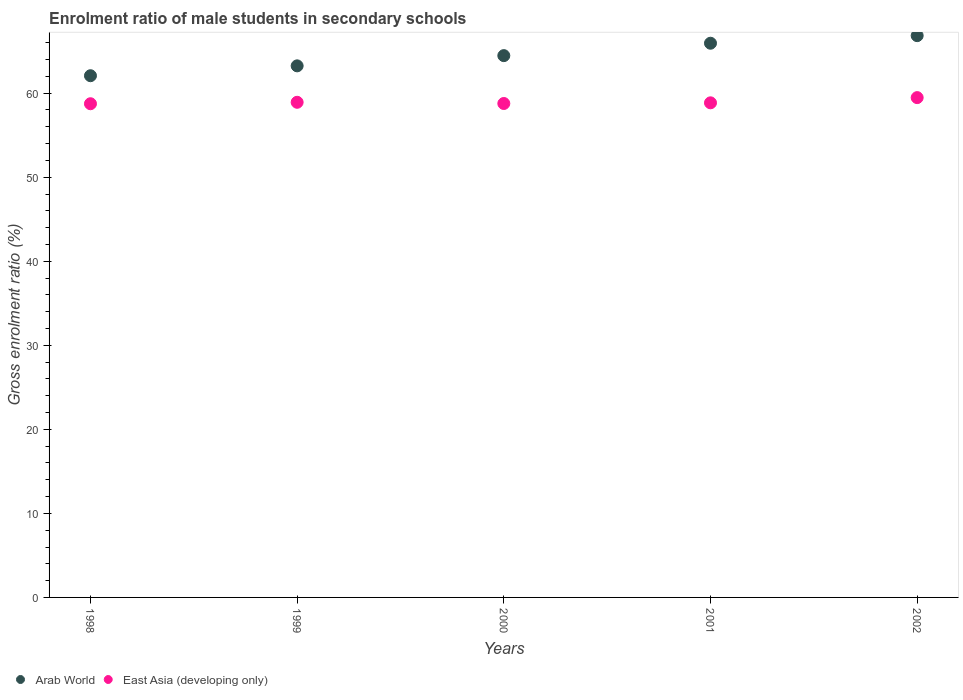Is the number of dotlines equal to the number of legend labels?
Your answer should be very brief. Yes. What is the enrolment ratio of male students in secondary schools in Arab World in 2000?
Your response must be concise. 64.47. Across all years, what is the maximum enrolment ratio of male students in secondary schools in East Asia (developing only)?
Your response must be concise. 59.47. Across all years, what is the minimum enrolment ratio of male students in secondary schools in Arab World?
Provide a succinct answer. 62.08. In which year was the enrolment ratio of male students in secondary schools in Arab World minimum?
Offer a terse response. 1998. What is the total enrolment ratio of male students in secondary schools in Arab World in the graph?
Ensure brevity in your answer.  322.58. What is the difference between the enrolment ratio of male students in secondary schools in East Asia (developing only) in 2000 and that in 2001?
Provide a succinct answer. -0.08. What is the difference between the enrolment ratio of male students in secondary schools in Arab World in 2001 and the enrolment ratio of male students in secondary schools in East Asia (developing only) in 2000?
Your answer should be compact. 7.17. What is the average enrolment ratio of male students in secondary schools in East Asia (developing only) per year?
Keep it short and to the point. 58.95. In the year 1999, what is the difference between the enrolment ratio of male students in secondary schools in Arab World and enrolment ratio of male students in secondary schools in East Asia (developing only)?
Provide a succinct answer. 4.33. What is the ratio of the enrolment ratio of male students in secondary schools in Arab World in 1998 to that in 2000?
Keep it short and to the point. 0.96. Is the enrolment ratio of male students in secondary schools in East Asia (developing only) in 1998 less than that in 2002?
Make the answer very short. Yes. What is the difference between the highest and the second highest enrolment ratio of male students in secondary schools in Arab World?
Offer a very short reply. 0.9. What is the difference between the highest and the lowest enrolment ratio of male students in secondary schools in East Asia (developing only)?
Offer a terse response. 0.73. Does the enrolment ratio of male students in secondary schools in Arab World monotonically increase over the years?
Offer a terse response. Yes. Is the enrolment ratio of male students in secondary schools in East Asia (developing only) strictly less than the enrolment ratio of male students in secondary schools in Arab World over the years?
Make the answer very short. Yes. How many dotlines are there?
Your response must be concise. 2. How many years are there in the graph?
Provide a succinct answer. 5. Are the values on the major ticks of Y-axis written in scientific E-notation?
Ensure brevity in your answer.  No. Does the graph contain grids?
Provide a succinct answer. No. Where does the legend appear in the graph?
Give a very brief answer. Bottom left. How many legend labels are there?
Your response must be concise. 2. How are the legend labels stacked?
Ensure brevity in your answer.  Horizontal. What is the title of the graph?
Give a very brief answer. Enrolment ratio of male students in secondary schools. Does "Nepal" appear as one of the legend labels in the graph?
Keep it short and to the point. No. What is the label or title of the X-axis?
Keep it short and to the point. Years. What is the Gross enrolment ratio (%) of Arab World in 1998?
Offer a very short reply. 62.08. What is the Gross enrolment ratio (%) in East Asia (developing only) in 1998?
Your response must be concise. 58.74. What is the Gross enrolment ratio (%) of Arab World in 1999?
Your answer should be very brief. 63.25. What is the Gross enrolment ratio (%) of East Asia (developing only) in 1999?
Offer a terse response. 58.92. What is the Gross enrolment ratio (%) of Arab World in 2000?
Offer a very short reply. 64.47. What is the Gross enrolment ratio (%) of East Asia (developing only) in 2000?
Give a very brief answer. 58.77. What is the Gross enrolment ratio (%) of Arab World in 2001?
Provide a succinct answer. 65.94. What is the Gross enrolment ratio (%) in East Asia (developing only) in 2001?
Your response must be concise. 58.85. What is the Gross enrolment ratio (%) in Arab World in 2002?
Make the answer very short. 66.84. What is the Gross enrolment ratio (%) of East Asia (developing only) in 2002?
Your answer should be very brief. 59.47. Across all years, what is the maximum Gross enrolment ratio (%) in Arab World?
Keep it short and to the point. 66.84. Across all years, what is the maximum Gross enrolment ratio (%) in East Asia (developing only)?
Offer a terse response. 59.47. Across all years, what is the minimum Gross enrolment ratio (%) of Arab World?
Make the answer very short. 62.08. Across all years, what is the minimum Gross enrolment ratio (%) in East Asia (developing only)?
Your response must be concise. 58.74. What is the total Gross enrolment ratio (%) in Arab World in the graph?
Your answer should be very brief. 322.58. What is the total Gross enrolment ratio (%) of East Asia (developing only) in the graph?
Offer a terse response. 294.75. What is the difference between the Gross enrolment ratio (%) of Arab World in 1998 and that in 1999?
Provide a short and direct response. -1.17. What is the difference between the Gross enrolment ratio (%) in East Asia (developing only) in 1998 and that in 1999?
Give a very brief answer. -0.17. What is the difference between the Gross enrolment ratio (%) of Arab World in 1998 and that in 2000?
Your answer should be very brief. -2.39. What is the difference between the Gross enrolment ratio (%) in East Asia (developing only) in 1998 and that in 2000?
Offer a terse response. -0.03. What is the difference between the Gross enrolment ratio (%) in Arab World in 1998 and that in 2001?
Provide a succinct answer. -3.87. What is the difference between the Gross enrolment ratio (%) of East Asia (developing only) in 1998 and that in 2001?
Give a very brief answer. -0.11. What is the difference between the Gross enrolment ratio (%) in Arab World in 1998 and that in 2002?
Make the answer very short. -4.77. What is the difference between the Gross enrolment ratio (%) in East Asia (developing only) in 1998 and that in 2002?
Offer a very short reply. -0.73. What is the difference between the Gross enrolment ratio (%) of Arab World in 1999 and that in 2000?
Offer a terse response. -1.22. What is the difference between the Gross enrolment ratio (%) in East Asia (developing only) in 1999 and that in 2000?
Offer a very short reply. 0.14. What is the difference between the Gross enrolment ratio (%) in Arab World in 1999 and that in 2001?
Make the answer very short. -2.69. What is the difference between the Gross enrolment ratio (%) in East Asia (developing only) in 1999 and that in 2001?
Keep it short and to the point. 0.06. What is the difference between the Gross enrolment ratio (%) in Arab World in 1999 and that in 2002?
Ensure brevity in your answer.  -3.59. What is the difference between the Gross enrolment ratio (%) of East Asia (developing only) in 1999 and that in 2002?
Ensure brevity in your answer.  -0.56. What is the difference between the Gross enrolment ratio (%) in Arab World in 2000 and that in 2001?
Give a very brief answer. -1.48. What is the difference between the Gross enrolment ratio (%) in East Asia (developing only) in 2000 and that in 2001?
Offer a very short reply. -0.08. What is the difference between the Gross enrolment ratio (%) in Arab World in 2000 and that in 2002?
Keep it short and to the point. -2.38. What is the difference between the Gross enrolment ratio (%) of East Asia (developing only) in 2000 and that in 2002?
Keep it short and to the point. -0.7. What is the difference between the Gross enrolment ratio (%) in Arab World in 2001 and that in 2002?
Your response must be concise. -0.9. What is the difference between the Gross enrolment ratio (%) of East Asia (developing only) in 2001 and that in 2002?
Give a very brief answer. -0.62. What is the difference between the Gross enrolment ratio (%) of Arab World in 1998 and the Gross enrolment ratio (%) of East Asia (developing only) in 1999?
Give a very brief answer. 3.16. What is the difference between the Gross enrolment ratio (%) in Arab World in 1998 and the Gross enrolment ratio (%) in East Asia (developing only) in 2000?
Your response must be concise. 3.31. What is the difference between the Gross enrolment ratio (%) of Arab World in 1998 and the Gross enrolment ratio (%) of East Asia (developing only) in 2001?
Make the answer very short. 3.23. What is the difference between the Gross enrolment ratio (%) of Arab World in 1998 and the Gross enrolment ratio (%) of East Asia (developing only) in 2002?
Give a very brief answer. 2.6. What is the difference between the Gross enrolment ratio (%) of Arab World in 1999 and the Gross enrolment ratio (%) of East Asia (developing only) in 2000?
Ensure brevity in your answer.  4.48. What is the difference between the Gross enrolment ratio (%) of Arab World in 1999 and the Gross enrolment ratio (%) of East Asia (developing only) in 2001?
Make the answer very short. 4.4. What is the difference between the Gross enrolment ratio (%) in Arab World in 1999 and the Gross enrolment ratio (%) in East Asia (developing only) in 2002?
Provide a succinct answer. 3.78. What is the difference between the Gross enrolment ratio (%) of Arab World in 2000 and the Gross enrolment ratio (%) of East Asia (developing only) in 2001?
Offer a terse response. 5.62. What is the difference between the Gross enrolment ratio (%) of Arab World in 2000 and the Gross enrolment ratio (%) of East Asia (developing only) in 2002?
Provide a succinct answer. 5. What is the difference between the Gross enrolment ratio (%) in Arab World in 2001 and the Gross enrolment ratio (%) in East Asia (developing only) in 2002?
Make the answer very short. 6.47. What is the average Gross enrolment ratio (%) in Arab World per year?
Provide a short and direct response. 64.52. What is the average Gross enrolment ratio (%) of East Asia (developing only) per year?
Offer a terse response. 58.95. In the year 1998, what is the difference between the Gross enrolment ratio (%) in Arab World and Gross enrolment ratio (%) in East Asia (developing only)?
Make the answer very short. 3.33. In the year 1999, what is the difference between the Gross enrolment ratio (%) in Arab World and Gross enrolment ratio (%) in East Asia (developing only)?
Provide a succinct answer. 4.33. In the year 2000, what is the difference between the Gross enrolment ratio (%) of Arab World and Gross enrolment ratio (%) of East Asia (developing only)?
Offer a very short reply. 5.7. In the year 2001, what is the difference between the Gross enrolment ratio (%) in Arab World and Gross enrolment ratio (%) in East Asia (developing only)?
Your response must be concise. 7.09. In the year 2002, what is the difference between the Gross enrolment ratio (%) in Arab World and Gross enrolment ratio (%) in East Asia (developing only)?
Keep it short and to the point. 7.37. What is the ratio of the Gross enrolment ratio (%) in Arab World in 1998 to that in 1999?
Ensure brevity in your answer.  0.98. What is the ratio of the Gross enrolment ratio (%) of East Asia (developing only) in 1998 to that in 1999?
Your response must be concise. 1. What is the ratio of the Gross enrolment ratio (%) in Arab World in 1998 to that in 2000?
Make the answer very short. 0.96. What is the ratio of the Gross enrolment ratio (%) in East Asia (developing only) in 1998 to that in 2000?
Keep it short and to the point. 1. What is the ratio of the Gross enrolment ratio (%) of Arab World in 1998 to that in 2001?
Offer a very short reply. 0.94. What is the ratio of the Gross enrolment ratio (%) of East Asia (developing only) in 1998 to that in 2001?
Your answer should be compact. 1. What is the ratio of the Gross enrolment ratio (%) in Arab World in 1998 to that in 2002?
Provide a short and direct response. 0.93. What is the ratio of the Gross enrolment ratio (%) in East Asia (developing only) in 1998 to that in 2002?
Offer a terse response. 0.99. What is the ratio of the Gross enrolment ratio (%) of Arab World in 1999 to that in 2000?
Provide a short and direct response. 0.98. What is the ratio of the Gross enrolment ratio (%) in East Asia (developing only) in 1999 to that in 2000?
Your answer should be compact. 1. What is the ratio of the Gross enrolment ratio (%) of Arab World in 1999 to that in 2001?
Offer a terse response. 0.96. What is the ratio of the Gross enrolment ratio (%) of Arab World in 1999 to that in 2002?
Offer a very short reply. 0.95. What is the ratio of the Gross enrolment ratio (%) of East Asia (developing only) in 1999 to that in 2002?
Your answer should be compact. 0.99. What is the ratio of the Gross enrolment ratio (%) in Arab World in 2000 to that in 2001?
Make the answer very short. 0.98. What is the ratio of the Gross enrolment ratio (%) of Arab World in 2000 to that in 2002?
Provide a short and direct response. 0.96. What is the ratio of the Gross enrolment ratio (%) in East Asia (developing only) in 2000 to that in 2002?
Keep it short and to the point. 0.99. What is the ratio of the Gross enrolment ratio (%) of Arab World in 2001 to that in 2002?
Ensure brevity in your answer.  0.99. What is the difference between the highest and the second highest Gross enrolment ratio (%) in Arab World?
Your answer should be compact. 0.9. What is the difference between the highest and the second highest Gross enrolment ratio (%) in East Asia (developing only)?
Keep it short and to the point. 0.56. What is the difference between the highest and the lowest Gross enrolment ratio (%) in Arab World?
Give a very brief answer. 4.77. What is the difference between the highest and the lowest Gross enrolment ratio (%) in East Asia (developing only)?
Make the answer very short. 0.73. 